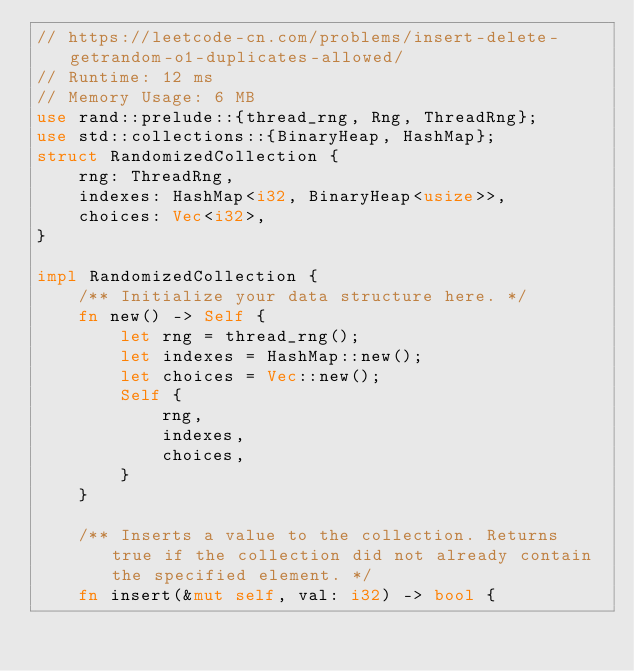<code> <loc_0><loc_0><loc_500><loc_500><_Rust_>// https://leetcode-cn.com/problems/insert-delete-getrandom-o1-duplicates-allowed/
// Runtime: 12 ms
// Memory Usage: 6 MB
use rand::prelude::{thread_rng, Rng, ThreadRng};
use std::collections::{BinaryHeap, HashMap};
struct RandomizedCollection {
    rng: ThreadRng,
    indexes: HashMap<i32, BinaryHeap<usize>>,
    choices: Vec<i32>,
}

impl RandomizedCollection {
    /** Initialize your data structure here. */
    fn new() -> Self {
        let rng = thread_rng();
        let indexes = HashMap::new();
        let choices = Vec::new();
        Self {
            rng,
            indexes,
            choices,
        }
    }

    /** Inserts a value to the collection. Returns true if the collection did not already contain the specified element. */
    fn insert(&mut self, val: i32) -> bool {</code> 